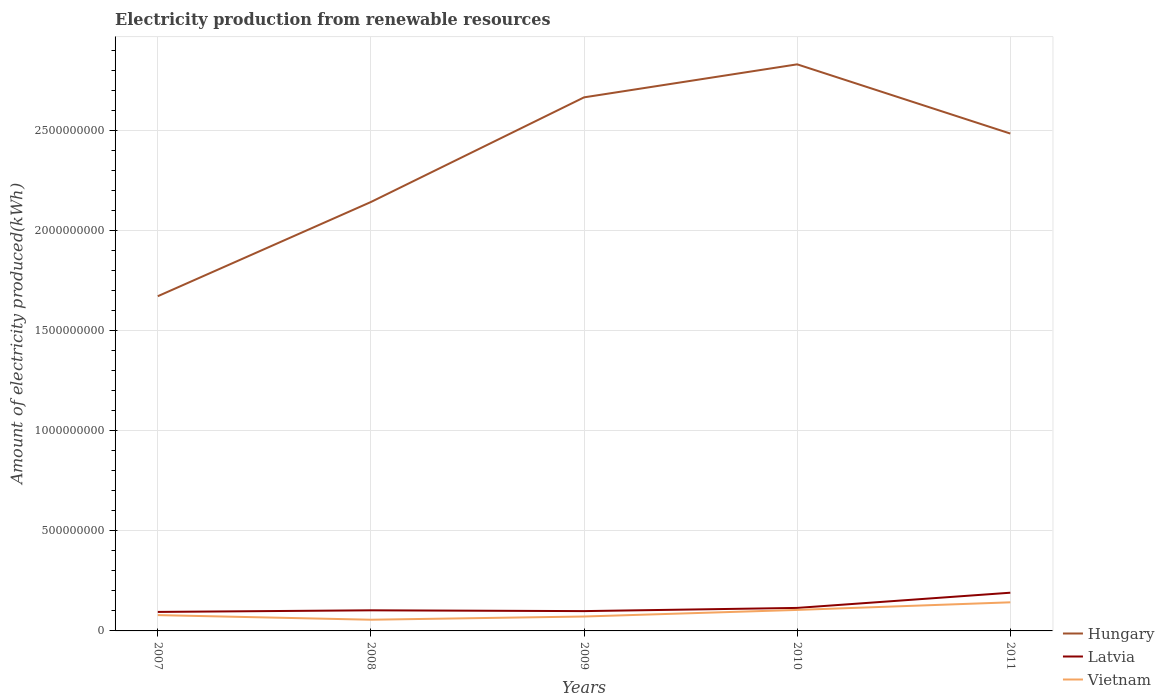Does the line corresponding to Hungary intersect with the line corresponding to Vietnam?
Ensure brevity in your answer.  No. Is the number of lines equal to the number of legend labels?
Give a very brief answer. Yes. Across all years, what is the maximum amount of electricity produced in Hungary?
Your response must be concise. 1.67e+09. What is the total amount of electricity produced in Vietnam in the graph?
Your response must be concise. -2.60e+07. What is the difference between the highest and the second highest amount of electricity produced in Hungary?
Provide a succinct answer. 1.16e+09. What is the difference between the highest and the lowest amount of electricity produced in Hungary?
Make the answer very short. 3. Is the amount of electricity produced in Latvia strictly greater than the amount of electricity produced in Vietnam over the years?
Your response must be concise. No. What is the difference between two consecutive major ticks on the Y-axis?
Your answer should be very brief. 5.00e+08. Does the graph contain any zero values?
Offer a very short reply. No. Where does the legend appear in the graph?
Your answer should be compact. Bottom right. How many legend labels are there?
Your response must be concise. 3. How are the legend labels stacked?
Your response must be concise. Vertical. What is the title of the graph?
Give a very brief answer. Electricity production from renewable resources. Does "Ukraine" appear as one of the legend labels in the graph?
Ensure brevity in your answer.  No. What is the label or title of the X-axis?
Make the answer very short. Years. What is the label or title of the Y-axis?
Give a very brief answer. Amount of electricity produced(kWh). What is the Amount of electricity produced(kWh) of Hungary in 2007?
Your answer should be very brief. 1.67e+09. What is the Amount of electricity produced(kWh) in Latvia in 2007?
Ensure brevity in your answer.  9.50e+07. What is the Amount of electricity produced(kWh) of Vietnam in 2007?
Your response must be concise. 7.90e+07. What is the Amount of electricity produced(kWh) in Hungary in 2008?
Make the answer very short. 2.14e+09. What is the Amount of electricity produced(kWh) in Latvia in 2008?
Provide a succinct answer. 1.03e+08. What is the Amount of electricity produced(kWh) in Vietnam in 2008?
Keep it short and to the point. 5.60e+07. What is the Amount of electricity produced(kWh) in Hungary in 2009?
Provide a short and direct response. 2.67e+09. What is the Amount of electricity produced(kWh) of Latvia in 2009?
Ensure brevity in your answer.  9.90e+07. What is the Amount of electricity produced(kWh) of Vietnam in 2009?
Offer a very short reply. 7.20e+07. What is the Amount of electricity produced(kWh) in Hungary in 2010?
Keep it short and to the point. 2.83e+09. What is the Amount of electricity produced(kWh) in Latvia in 2010?
Your response must be concise. 1.15e+08. What is the Amount of electricity produced(kWh) in Vietnam in 2010?
Offer a very short reply. 1.05e+08. What is the Amount of electricity produced(kWh) in Hungary in 2011?
Your answer should be compact. 2.49e+09. What is the Amount of electricity produced(kWh) of Latvia in 2011?
Ensure brevity in your answer.  1.91e+08. What is the Amount of electricity produced(kWh) of Vietnam in 2011?
Your answer should be very brief. 1.43e+08. Across all years, what is the maximum Amount of electricity produced(kWh) in Hungary?
Offer a very short reply. 2.83e+09. Across all years, what is the maximum Amount of electricity produced(kWh) of Latvia?
Give a very brief answer. 1.91e+08. Across all years, what is the maximum Amount of electricity produced(kWh) in Vietnam?
Offer a terse response. 1.43e+08. Across all years, what is the minimum Amount of electricity produced(kWh) of Hungary?
Keep it short and to the point. 1.67e+09. Across all years, what is the minimum Amount of electricity produced(kWh) of Latvia?
Your answer should be compact. 9.50e+07. Across all years, what is the minimum Amount of electricity produced(kWh) of Vietnam?
Offer a very short reply. 5.60e+07. What is the total Amount of electricity produced(kWh) in Hungary in the graph?
Make the answer very short. 1.18e+1. What is the total Amount of electricity produced(kWh) in Latvia in the graph?
Provide a succinct answer. 6.03e+08. What is the total Amount of electricity produced(kWh) in Vietnam in the graph?
Make the answer very short. 4.55e+08. What is the difference between the Amount of electricity produced(kWh) of Hungary in 2007 and that in 2008?
Give a very brief answer. -4.71e+08. What is the difference between the Amount of electricity produced(kWh) in Latvia in 2007 and that in 2008?
Offer a terse response. -8.00e+06. What is the difference between the Amount of electricity produced(kWh) of Vietnam in 2007 and that in 2008?
Offer a terse response. 2.30e+07. What is the difference between the Amount of electricity produced(kWh) in Hungary in 2007 and that in 2009?
Offer a very short reply. -9.94e+08. What is the difference between the Amount of electricity produced(kWh) of Vietnam in 2007 and that in 2009?
Give a very brief answer. 7.00e+06. What is the difference between the Amount of electricity produced(kWh) in Hungary in 2007 and that in 2010?
Ensure brevity in your answer.  -1.16e+09. What is the difference between the Amount of electricity produced(kWh) of Latvia in 2007 and that in 2010?
Provide a succinct answer. -2.00e+07. What is the difference between the Amount of electricity produced(kWh) of Vietnam in 2007 and that in 2010?
Your answer should be very brief. -2.60e+07. What is the difference between the Amount of electricity produced(kWh) in Hungary in 2007 and that in 2011?
Your answer should be very brief. -8.13e+08. What is the difference between the Amount of electricity produced(kWh) of Latvia in 2007 and that in 2011?
Your answer should be very brief. -9.60e+07. What is the difference between the Amount of electricity produced(kWh) of Vietnam in 2007 and that in 2011?
Provide a succinct answer. -6.40e+07. What is the difference between the Amount of electricity produced(kWh) of Hungary in 2008 and that in 2009?
Offer a very short reply. -5.23e+08. What is the difference between the Amount of electricity produced(kWh) in Latvia in 2008 and that in 2009?
Your answer should be compact. 4.00e+06. What is the difference between the Amount of electricity produced(kWh) in Vietnam in 2008 and that in 2009?
Keep it short and to the point. -1.60e+07. What is the difference between the Amount of electricity produced(kWh) of Hungary in 2008 and that in 2010?
Give a very brief answer. -6.88e+08. What is the difference between the Amount of electricity produced(kWh) in Latvia in 2008 and that in 2010?
Keep it short and to the point. -1.20e+07. What is the difference between the Amount of electricity produced(kWh) of Vietnam in 2008 and that in 2010?
Provide a succinct answer. -4.90e+07. What is the difference between the Amount of electricity produced(kWh) of Hungary in 2008 and that in 2011?
Your answer should be compact. -3.42e+08. What is the difference between the Amount of electricity produced(kWh) of Latvia in 2008 and that in 2011?
Ensure brevity in your answer.  -8.80e+07. What is the difference between the Amount of electricity produced(kWh) in Vietnam in 2008 and that in 2011?
Ensure brevity in your answer.  -8.70e+07. What is the difference between the Amount of electricity produced(kWh) in Hungary in 2009 and that in 2010?
Provide a succinct answer. -1.65e+08. What is the difference between the Amount of electricity produced(kWh) in Latvia in 2009 and that in 2010?
Your answer should be very brief. -1.60e+07. What is the difference between the Amount of electricity produced(kWh) of Vietnam in 2009 and that in 2010?
Your answer should be compact. -3.30e+07. What is the difference between the Amount of electricity produced(kWh) of Hungary in 2009 and that in 2011?
Give a very brief answer. 1.81e+08. What is the difference between the Amount of electricity produced(kWh) in Latvia in 2009 and that in 2011?
Offer a very short reply. -9.20e+07. What is the difference between the Amount of electricity produced(kWh) of Vietnam in 2009 and that in 2011?
Offer a terse response. -7.10e+07. What is the difference between the Amount of electricity produced(kWh) in Hungary in 2010 and that in 2011?
Make the answer very short. 3.46e+08. What is the difference between the Amount of electricity produced(kWh) in Latvia in 2010 and that in 2011?
Provide a short and direct response. -7.60e+07. What is the difference between the Amount of electricity produced(kWh) in Vietnam in 2010 and that in 2011?
Provide a short and direct response. -3.80e+07. What is the difference between the Amount of electricity produced(kWh) of Hungary in 2007 and the Amount of electricity produced(kWh) of Latvia in 2008?
Your answer should be very brief. 1.57e+09. What is the difference between the Amount of electricity produced(kWh) in Hungary in 2007 and the Amount of electricity produced(kWh) in Vietnam in 2008?
Give a very brief answer. 1.62e+09. What is the difference between the Amount of electricity produced(kWh) of Latvia in 2007 and the Amount of electricity produced(kWh) of Vietnam in 2008?
Offer a terse response. 3.90e+07. What is the difference between the Amount of electricity produced(kWh) in Hungary in 2007 and the Amount of electricity produced(kWh) in Latvia in 2009?
Provide a succinct answer. 1.57e+09. What is the difference between the Amount of electricity produced(kWh) in Hungary in 2007 and the Amount of electricity produced(kWh) in Vietnam in 2009?
Provide a succinct answer. 1.60e+09. What is the difference between the Amount of electricity produced(kWh) in Latvia in 2007 and the Amount of electricity produced(kWh) in Vietnam in 2009?
Keep it short and to the point. 2.30e+07. What is the difference between the Amount of electricity produced(kWh) of Hungary in 2007 and the Amount of electricity produced(kWh) of Latvia in 2010?
Offer a very short reply. 1.56e+09. What is the difference between the Amount of electricity produced(kWh) of Hungary in 2007 and the Amount of electricity produced(kWh) of Vietnam in 2010?
Ensure brevity in your answer.  1.57e+09. What is the difference between the Amount of electricity produced(kWh) in Latvia in 2007 and the Amount of electricity produced(kWh) in Vietnam in 2010?
Your answer should be compact. -1.00e+07. What is the difference between the Amount of electricity produced(kWh) in Hungary in 2007 and the Amount of electricity produced(kWh) in Latvia in 2011?
Your answer should be very brief. 1.48e+09. What is the difference between the Amount of electricity produced(kWh) in Hungary in 2007 and the Amount of electricity produced(kWh) in Vietnam in 2011?
Make the answer very short. 1.53e+09. What is the difference between the Amount of electricity produced(kWh) in Latvia in 2007 and the Amount of electricity produced(kWh) in Vietnam in 2011?
Your answer should be compact. -4.80e+07. What is the difference between the Amount of electricity produced(kWh) of Hungary in 2008 and the Amount of electricity produced(kWh) of Latvia in 2009?
Offer a very short reply. 2.04e+09. What is the difference between the Amount of electricity produced(kWh) in Hungary in 2008 and the Amount of electricity produced(kWh) in Vietnam in 2009?
Provide a short and direct response. 2.07e+09. What is the difference between the Amount of electricity produced(kWh) of Latvia in 2008 and the Amount of electricity produced(kWh) of Vietnam in 2009?
Your answer should be very brief. 3.10e+07. What is the difference between the Amount of electricity produced(kWh) in Hungary in 2008 and the Amount of electricity produced(kWh) in Latvia in 2010?
Ensure brevity in your answer.  2.03e+09. What is the difference between the Amount of electricity produced(kWh) of Hungary in 2008 and the Amount of electricity produced(kWh) of Vietnam in 2010?
Give a very brief answer. 2.04e+09. What is the difference between the Amount of electricity produced(kWh) in Hungary in 2008 and the Amount of electricity produced(kWh) in Latvia in 2011?
Ensure brevity in your answer.  1.95e+09. What is the difference between the Amount of electricity produced(kWh) of Hungary in 2008 and the Amount of electricity produced(kWh) of Vietnam in 2011?
Give a very brief answer. 2.00e+09. What is the difference between the Amount of electricity produced(kWh) of Latvia in 2008 and the Amount of electricity produced(kWh) of Vietnam in 2011?
Your answer should be very brief. -4.00e+07. What is the difference between the Amount of electricity produced(kWh) in Hungary in 2009 and the Amount of electricity produced(kWh) in Latvia in 2010?
Ensure brevity in your answer.  2.55e+09. What is the difference between the Amount of electricity produced(kWh) in Hungary in 2009 and the Amount of electricity produced(kWh) in Vietnam in 2010?
Ensure brevity in your answer.  2.56e+09. What is the difference between the Amount of electricity produced(kWh) in Latvia in 2009 and the Amount of electricity produced(kWh) in Vietnam in 2010?
Offer a very short reply. -6.00e+06. What is the difference between the Amount of electricity produced(kWh) of Hungary in 2009 and the Amount of electricity produced(kWh) of Latvia in 2011?
Ensure brevity in your answer.  2.48e+09. What is the difference between the Amount of electricity produced(kWh) of Hungary in 2009 and the Amount of electricity produced(kWh) of Vietnam in 2011?
Ensure brevity in your answer.  2.52e+09. What is the difference between the Amount of electricity produced(kWh) in Latvia in 2009 and the Amount of electricity produced(kWh) in Vietnam in 2011?
Your answer should be very brief. -4.40e+07. What is the difference between the Amount of electricity produced(kWh) in Hungary in 2010 and the Amount of electricity produced(kWh) in Latvia in 2011?
Offer a terse response. 2.64e+09. What is the difference between the Amount of electricity produced(kWh) in Hungary in 2010 and the Amount of electricity produced(kWh) in Vietnam in 2011?
Your answer should be very brief. 2.69e+09. What is the difference between the Amount of electricity produced(kWh) in Latvia in 2010 and the Amount of electricity produced(kWh) in Vietnam in 2011?
Offer a terse response. -2.80e+07. What is the average Amount of electricity produced(kWh) in Hungary per year?
Keep it short and to the point. 2.36e+09. What is the average Amount of electricity produced(kWh) in Latvia per year?
Make the answer very short. 1.21e+08. What is the average Amount of electricity produced(kWh) in Vietnam per year?
Give a very brief answer. 9.10e+07. In the year 2007, what is the difference between the Amount of electricity produced(kWh) of Hungary and Amount of electricity produced(kWh) of Latvia?
Your answer should be compact. 1.58e+09. In the year 2007, what is the difference between the Amount of electricity produced(kWh) of Hungary and Amount of electricity produced(kWh) of Vietnam?
Provide a succinct answer. 1.59e+09. In the year 2007, what is the difference between the Amount of electricity produced(kWh) of Latvia and Amount of electricity produced(kWh) of Vietnam?
Provide a succinct answer. 1.60e+07. In the year 2008, what is the difference between the Amount of electricity produced(kWh) in Hungary and Amount of electricity produced(kWh) in Latvia?
Give a very brief answer. 2.04e+09. In the year 2008, what is the difference between the Amount of electricity produced(kWh) in Hungary and Amount of electricity produced(kWh) in Vietnam?
Ensure brevity in your answer.  2.09e+09. In the year 2008, what is the difference between the Amount of electricity produced(kWh) in Latvia and Amount of electricity produced(kWh) in Vietnam?
Your answer should be very brief. 4.70e+07. In the year 2009, what is the difference between the Amount of electricity produced(kWh) in Hungary and Amount of electricity produced(kWh) in Latvia?
Keep it short and to the point. 2.57e+09. In the year 2009, what is the difference between the Amount of electricity produced(kWh) of Hungary and Amount of electricity produced(kWh) of Vietnam?
Give a very brief answer. 2.60e+09. In the year 2009, what is the difference between the Amount of electricity produced(kWh) of Latvia and Amount of electricity produced(kWh) of Vietnam?
Give a very brief answer. 2.70e+07. In the year 2010, what is the difference between the Amount of electricity produced(kWh) in Hungary and Amount of electricity produced(kWh) in Latvia?
Make the answer very short. 2.72e+09. In the year 2010, what is the difference between the Amount of electricity produced(kWh) of Hungary and Amount of electricity produced(kWh) of Vietnam?
Your response must be concise. 2.73e+09. In the year 2011, what is the difference between the Amount of electricity produced(kWh) of Hungary and Amount of electricity produced(kWh) of Latvia?
Provide a short and direct response. 2.30e+09. In the year 2011, what is the difference between the Amount of electricity produced(kWh) of Hungary and Amount of electricity produced(kWh) of Vietnam?
Your answer should be compact. 2.34e+09. In the year 2011, what is the difference between the Amount of electricity produced(kWh) of Latvia and Amount of electricity produced(kWh) of Vietnam?
Your answer should be very brief. 4.80e+07. What is the ratio of the Amount of electricity produced(kWh) of Hungary in 2007 to that in 2008?
Your answer should be compact. 0.78. What is the ratio of the Amount of electricity produced(kWh) of Latvia in 2007 to that in 2008?
Provide a short and direct response. 0.92. What is the ratio of the Amount of electricity produced(kWh) in Vietnam in 2007 to that in 2008?
Offer a very short reply. 1.41. What is the ratio of the Amount of electricity produced(kWh) in Hungary in 2007 to that in 2009?
Your answer should be compact. 0.63. What is the ratio of the Amount of electricity produced(kWh) in Latvia in 2007 to that in 2009?
Your response must be concise. 0.96. What is the ratio of the Amount of electricity produced(kWh) of Vietnam in 2007 to that in 2009?
Your response must be concise. 1.1. What is the ratio of the Amount of electricity produced(kWh) of Hungary in 2007 to that in 2010?
Offer a very short reply. 0.59. What is the ratio of the Amount of electricity produced(kWh) of Latvia in 2007 to that in 2010?
Make the answer very short. 0.83. What is the ratio of the Amount of electricity produced(kWh) of Vietnam in 2007 to that in 2010?
Offer a very short reply. 0.75. What is the ratio of the Amount of electricity produced(kWh) of Hungary in 2007 to that in 2011?
Keep it short and to the point. 0.67. What is the ratio of the Amount of electricity produced(kWh) of Latvia in 2007 to that in 2011?
Offer a terse response. 0.5. What is the ratio of the Amount of electricity produced(kWh) in Vietnam in 2007 to that in 2011?
Provide a short and direct response. 0.55. What is the ratio of the Amount of electricity produced(kWh) in Hungary in 2008 to that in 2009?
Give a very brief answer. 0.8. What is the ratio of the Amount of electricity produced(kWh) in Latvia in 2008 to that in 2009?
Offer a very short reply. 1.04. What is the ratio of the Amount of electricity produced(kWh) in Vietnam in 2008 to that in 2009?
Offer a terse response. 0.78. What is the ratio of the Amount of electricity produced(kWh) in Hungary in 2008 to that in 2010?
Ensure brevity in your answer.  0.76. What is the ratio of the Amount of electricity produced(kWh) of Latvia in 2008 to that in 2010?
Provide a short and direct response. 0.9. What is the ratio of the Amount of electricity produced(kWh) of Vietnam in 2008 to that in 2010?
Make the answer very short. 0.53. What is the ratio of the Amount of electricity produced(kWh) of Hungary in 2008 to that in 2011?
Keep it short and to the point. 0.86. What is the ratio of the Amount of electricity produced(kWh) in Latvia in 2008 to that in 2011?
Ensure brevity in your answer.  0.54. What is the ratio of the Amount of electricity produced(kWh) in Vietnam in 2008 to that in 2011?
Offer a very short reply. 0.39. What is the ratio of the Amount of electricity produced(kWh) of Hungary in 2009 to that in 2010?
Ensure brevity in your answer.  0.94. What is the ratio of the Amount of electricity produced(kWh) of Latvia in 2009 to that in 2010?
Ensure brevity in your answer.  0.86. What is the ratio of the Amount of electricity produced(kWh) of Vietnam in 2009 to that in 2010?
Make the answer very short. 0.69. What is the ratio of the Amount of electricity produced(kWh) in Hungary in 2009 to that in 2011?
Offer a terse response. 1.07. What is the ratio of the Amount of electricity produced(kWh) of Latvia in 2009 to that in 2011?
Your answer should be compact. 0.52. What is the ratio of the Amount of electricity produced(kWh) in Vietnam in 2009 to that in 2011?
Make the answer very short. 0.5. What is the ratio of the Amount of electricity produced(kWh) in Hungary in 2010 to that in 2011?
Give a very brief answer. 1.14. What is the ratio of the Amount of electricity produced(kWh) in Latvia in 2010 to that in 2011?
Keep it short and to the point. 0.6. What is the ratio of the Amount of electricity produced(kWh) in Vietnam in 2010 to that in 2011?
Keep it short and to the point. 0.73. What is the difference between the highest and the second highest Amount of electricity produced(kWh) of Hungary?
Your answer should be very brief. 1.65e+08. What is the difference between the highest and the second highest Amount of electricity produced(kWh) in Latvia?
Offer a terse response. 7.60e+07. What is the difference between the highest and the second highest Amount of electricity produced(kWh) of Vietnam?
Make the answer very short. 3.80e+07. What is the difference between the highest and the lowest Amount of electricity produced(kWh) of Hungary?
Make the answer very short. 1.16e+09. What is the difference between the highest and the lowest Amount of electricity produced(kWh) of Latvia?
Your answer should be compact. 9.60e+07. What is the difference between the highest and the lowest Amount of electricity produced(kWh) in Vietnam?
Give a very brief answer. 8.70e+07. 